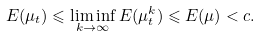<formula> <loc_0><loc_0><loc_500><loc_500>E ( \mu _ { t } ) \leqslant \liminf _ { k \to \infty } E ( \mu _ { t } ^ { k } ) \leqslant E ( \mu ) < c .</formula> 